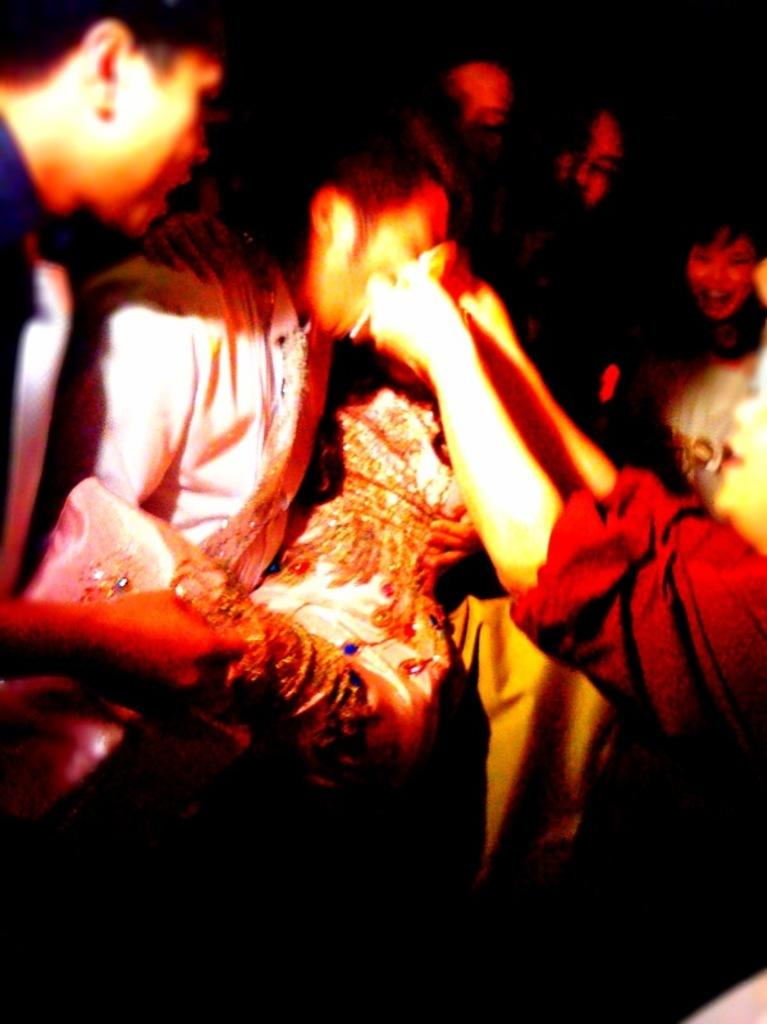How many individuals can be seen in the image? There are many people in the image. What type of pen is being used by the person in the middle of the image? There is no pen or person in the middle of the image; it only shows a group of people. 